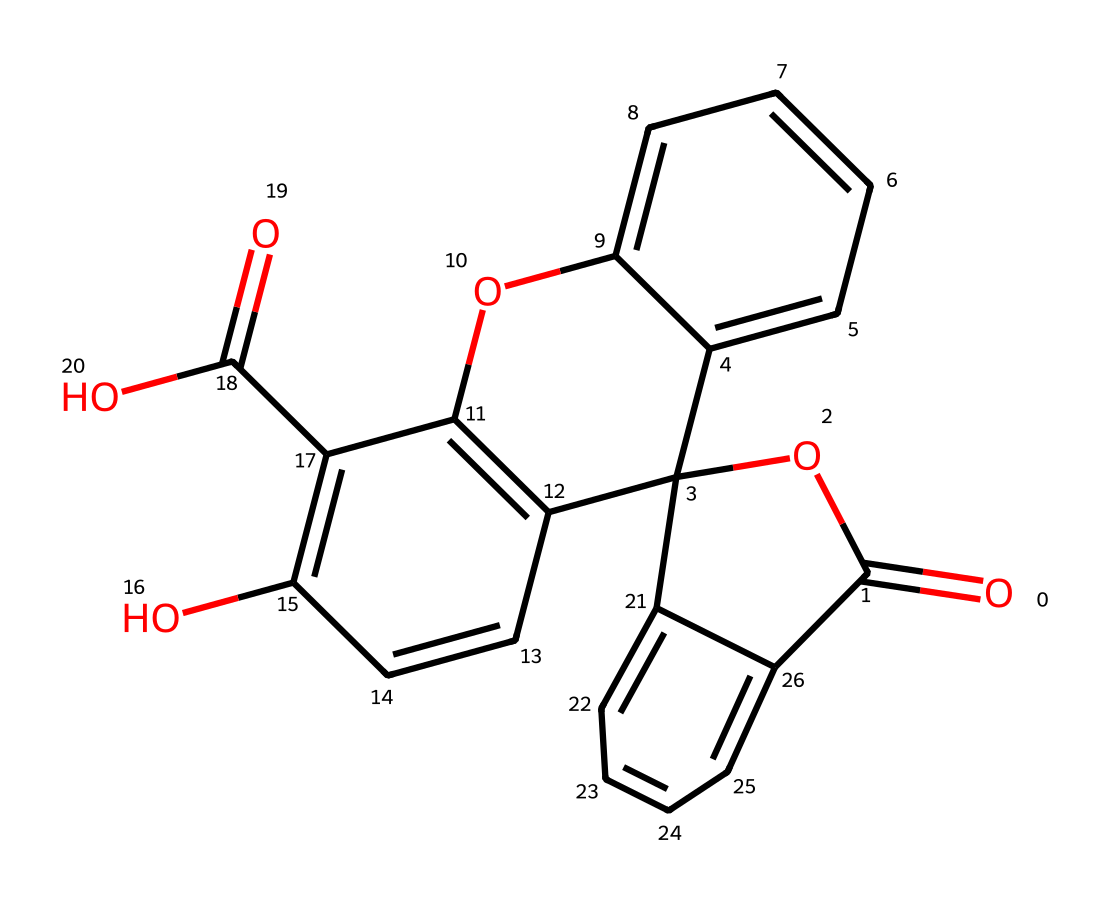What type of compound is indicated by the structure? The presence of multiple aromatic rings and functional groups such as carbonyl and hydroxyl indicates that this compound is an organic dye.
Answer: organic dye How many carbon atoms are present in the structure? By analyzing the SMILES, we can count the number of carbon atoms in the rings and side groups which totals to 15.
Answer: 15 What functional groups are present in this dye? The structure shows the presence of hydroxyl (-OH) groups and carbonyl (C=O) groups in the molecule, indicating it is a polyfunctional dye.
Answer: hydroxyl and carbonyl What is the molecular formula derived from the structure? Analyzing the SMILES representation reveals that the total composition results in a molecular formula of C15H12O4.
Answer: C15H12O4 How many aromatic rings are present in the structure? There are 5 distinct aromatic rings based on the pattern of the carbon atoms and the alternating double bonds, which are characteristic of aromatic compounds.
Answer: 5 What is the likely color imparted by this type of dye? Fluorescent dyes are often vivid in color owing to their structure; they likely exhibit bright colors, typically yellow, green, or blue, depending on the substituents.
Answer: bright Is this structure more likely to be soluble in water or organic solvents? The presence of multiple hydrophobic aromatic rings suggests that this dye is more soluble in organic solvents than in water.
Answer: organic solvents 